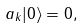<formula> <loc_0><loc_0><loc_500><loc_500>a _ { k } | 0 \rangle = 0 ,</formula> 